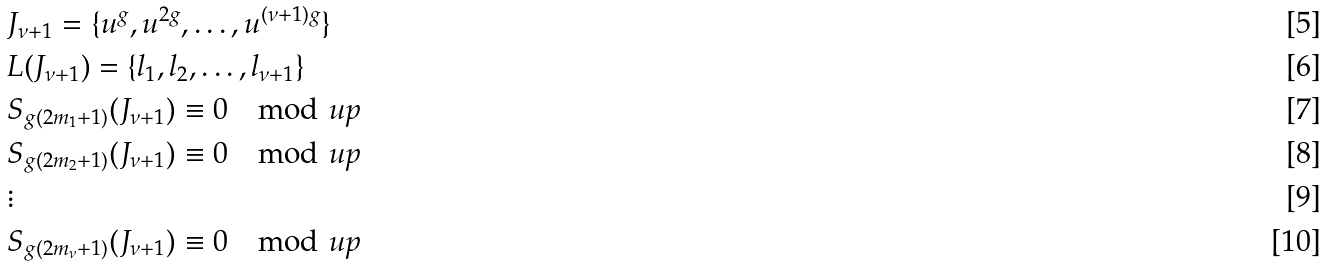<formula> <loc_0><loc_0><loc_500><loc_500>& J _ { \nu + 1 } = \{ u ^ { g } , u ^ { 2 g } , \dots , u ^ { ( \nu + 1 ) g } \} \\ & L ( J _ { \nu + 1 } ) = \{ l _ { 1 } , l _ { 2 } , \dots , l _ { \nu + 1 } \} \\ & S _ { g ( 2 m _ { 1 } + 1 ) } ( J _ { \nu + 1 } ) \equiv 0 \mod u p \\ & S _ { g ( 2 m _ { 2 } + 1 ) } ( J _ { \nu + 1 } ) \equiv 0 \mod u p \\ & \vdots \\ & S _ { g ( 2 m _ { \nu } + 1 ) } ( J _ { \nu + 1 } ) \equiv 0 \mod u p</formula> 